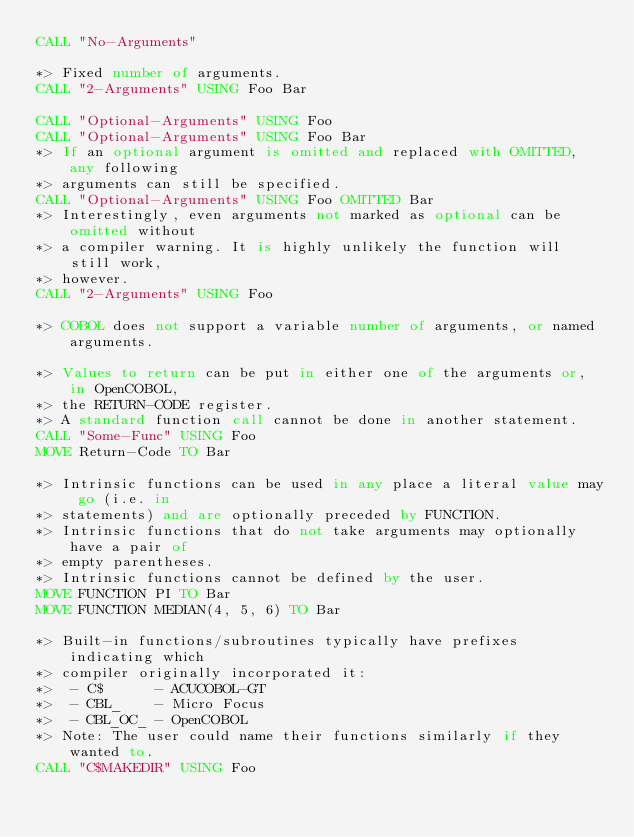Convert code to text. <code><loc_0><loc_0><loc_500><loc_500><_COBOL_>CALL "No-Arguments"

*> Fixed number of arguments.
CALL "2-Arguments" USING Foo Bar

CALL "Optional-Arguments" USING Foo
CALL "Optional-Arguments" USING Foo Bar
*> If an optional argument is omitted and replaced with OMITTED, any following
*> arguments can still be specified.
CALL "Optional-Arguments" USING Foo OMITTED Bar
*> Interestingly, even arguments not marked as optional can be omitted without
*> a compiler warning. It is highly unlikely the function will still work,
*> however.
CALL "2-Arguments" USING Foo

*> COBOL does not support a variable number of arguments, or named arguments.

*> Values to return can be put in either one of the arguments or, in OpenCOBOL,
*> the RETURN-CODE register.
*> A standard function call cannot be done in another statement.
CALL "Some-Func" USING Foo
MOVE Return-Code TO Bar

*> Intrinsic functions can be used in any place a literal value may go (i.e. in
*> statements) and are optionally preceded by FUNCTION.
*> Intrinsic functions that do not take arguments may optionally have a pair of
*> empty parentheses.
*> Intrinsic functions cannot be defined by the user.
MOVE FUNCTION PI TO Bar
MOVE FUNCTION MEDIAN(4, 5, 6) TO Bar

*> Built-in functions/subroutines typically have prefixes indicating which
*> compiler originally incorporated it:
*>  - C$      - ACUCOBOL-GT
*>  - CBL_    - Micro Focus
*>  - CBL_OC_ - OpenCOBOL
*> Note: The user could name their functions similarly if they wanted to.
CALL "C$MAKEDIR" USING Foo</code> 